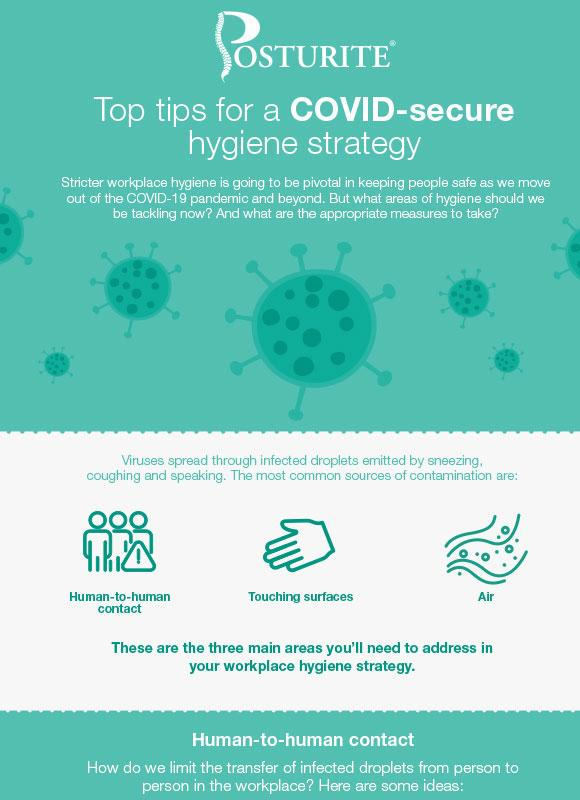Indicate a few pertinent items in this graphic. The infographic depicts 3 common sources of contamination. The second source through which the disease can spread is by touching contaminated surfaces. 